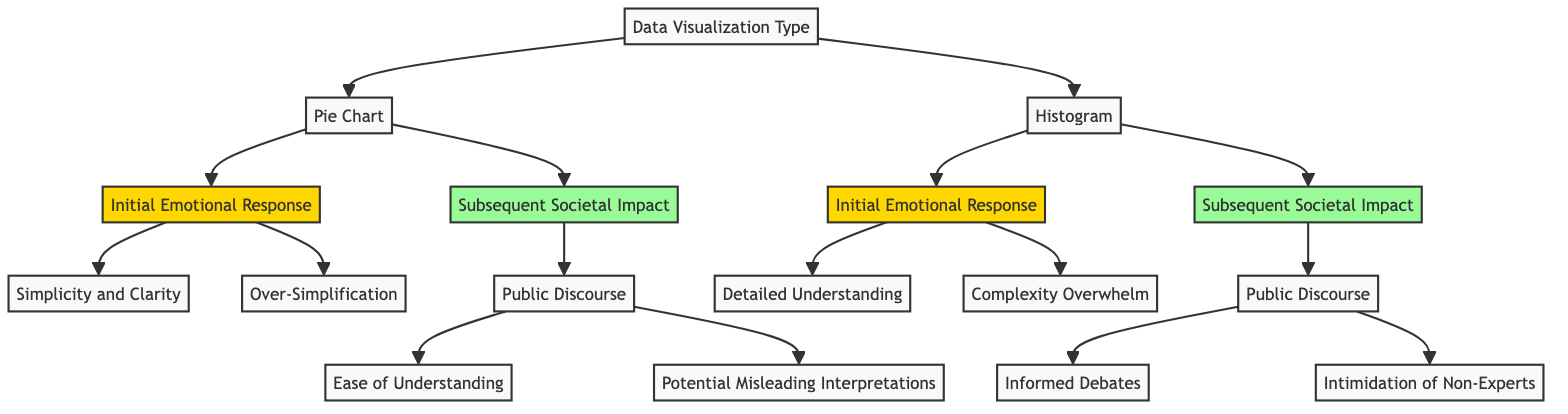What are the two main types of data visualizations presented in the diagram? The diagram identifies "Pie Chart" and "Histogram" as the two main types of data visualizations. These are displayed as child nodes under the main node, "Data Visualization Type."
Answer: Pie Chart, Histogram What is the first emotional response triggered by a Pie Chart? The diagram indicates that the first emotional response from a Pie Chart is categorized into two types. Specifically, "Simplicity and Clarity" is listed as one of the responses.
Answer: Simplicity and Clarity How many initial emotional responses are associated with the Histogram? There are two initial emotional responses listed under Histogram: "Detailed Understanding" and "Complexity Overwhelm." Therefore, the total count is two.
Answer: 2 What societal impact stems from the initial emotional response of "Complexity Overwhelm"? Following the emotional response of "Complexity Overwhelm," the diagram outlines the subsequent societal impact which occurs in the context of "Public Discourse," leading to "Intimidation of Non-Experts."
Answer: Intimidation of Non-Experts Which emotional response directly relates to "Ease of Understanding"? According to the diagram, "Ease of Understanding" is linked to the societal impact category under the Pie Chart's "Public Discourse" node, which stems from the initial emotional response to the Pie Chart.
Answer: Ease of Understanding What is the relationship between "Public Discourse" and "Informed Debates"? The diagram illustrates that both "Informed Debates" and "Intimidation of Non-Experts" are outcomes of the "Public Discourse" stemming from a Histogram. These are both child nodes linked to the "Public Discourse" node under Histogram's societal impact.
Answer: Outcome of Histogram What is a potential negative interpretation of a Pie Chart according to the diagram? The diagram presents "Potential Misleading Interpretations" as a possible negative outcome tied to the Pie Chart's societal impact under "Public Discourse," indicating a critical view of the simplification inherent in this visualization style.
Answer: Potential Misleading Interpretations Which emotional response is associated with detailed understanding? The diagram indicates that "Detailed Understanding" is identified as the initial emotional response invoked by a Histogram, suggesting it promotes comprehension of the data's complexity.
Answer: Detailed Understanding 